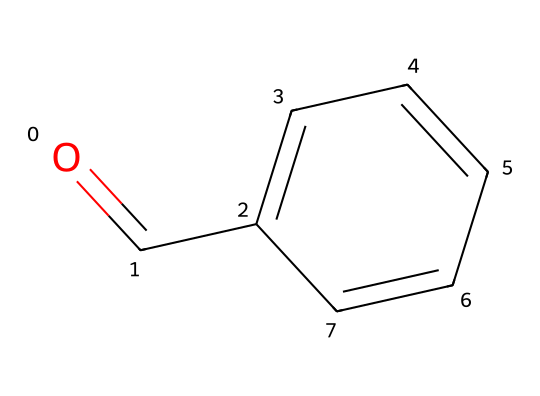What is the chemical name of this compound? The SMILES representation identifies the compound, which is benzaldehyde, a common aromatic compound known for its almond scent.
Answer: benzaldehyde How many carbon atoms are present in the structure? The SMILES indicates that there are six carbon atoms in the benzene ring plus one carbon atom in the aldehyde group, totaling seven carbon atoms.
Answer: seven What functional group is present in benzaldehyde? The presence of the carbonyl group (C=O) in the structure indicates that the functional group in benzaldehyde is an aldehyde.
Answer: aldehyde How many hydrogen atoms are in benzaldehyde? Analyzing the structure reveals that each carbon in the benzene ring typically bonds to one hydrogen, and the aldehyde contributes one hydrogen, resulting in five hydrogen atoms.
Answer: five Is this compound polar or nonpolar? The presence of the polar carbonyl functional group and the nonpolar aromatic ring suggests that benzaldehyde is a polar compound overall.
Answer: polar What type of hydrocarbon is benzaldehyde classified as? Benzaldehyde contains a benzene ring as its main structure, which is characteristic of aromatic hydrocarbons, indicating that it is an aromatic compound.
Answer: aromatic What is the molecular formula of benzaldehyde? By counting the atoms from the structure, we find there are seven carbon atoms, six hydrogen atoms, and one oxygen atom, giving the molecular formula C7H6O.
Answer: C7H6O 